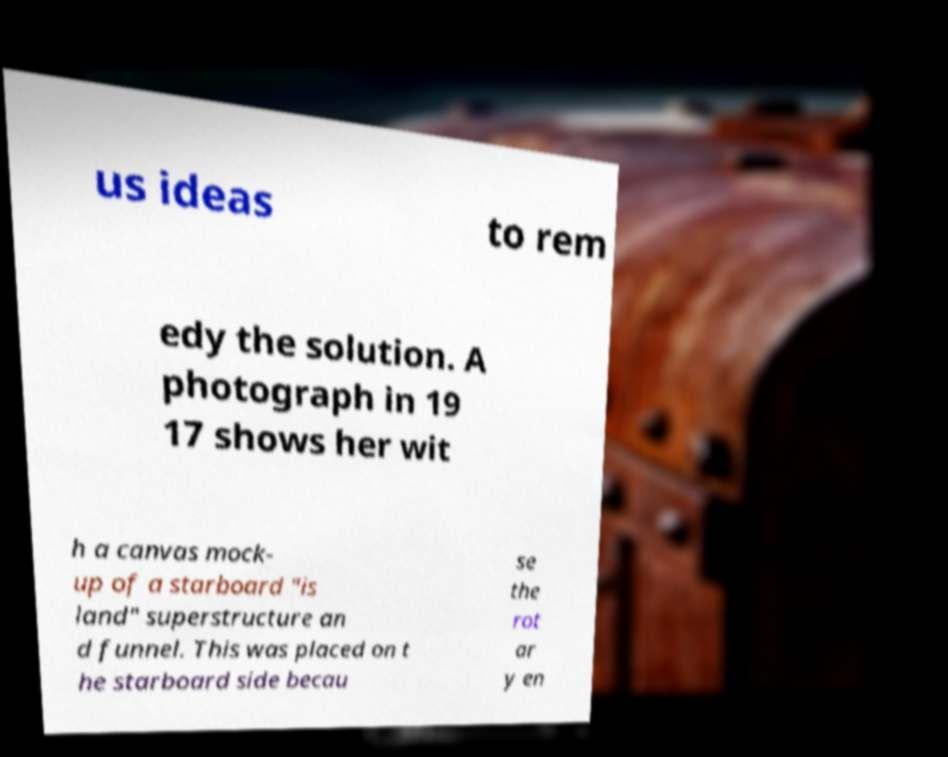There's text embedded in this image that I need extracted. Can you transcribe it verbatim? us ideas to rem edy the solution. A photograph in 19 17 shows her wit h a canvas mock- up of a starboard "is land" superstructure an d funnel. This was placed on t he starboard side becau se the rot ar y en 